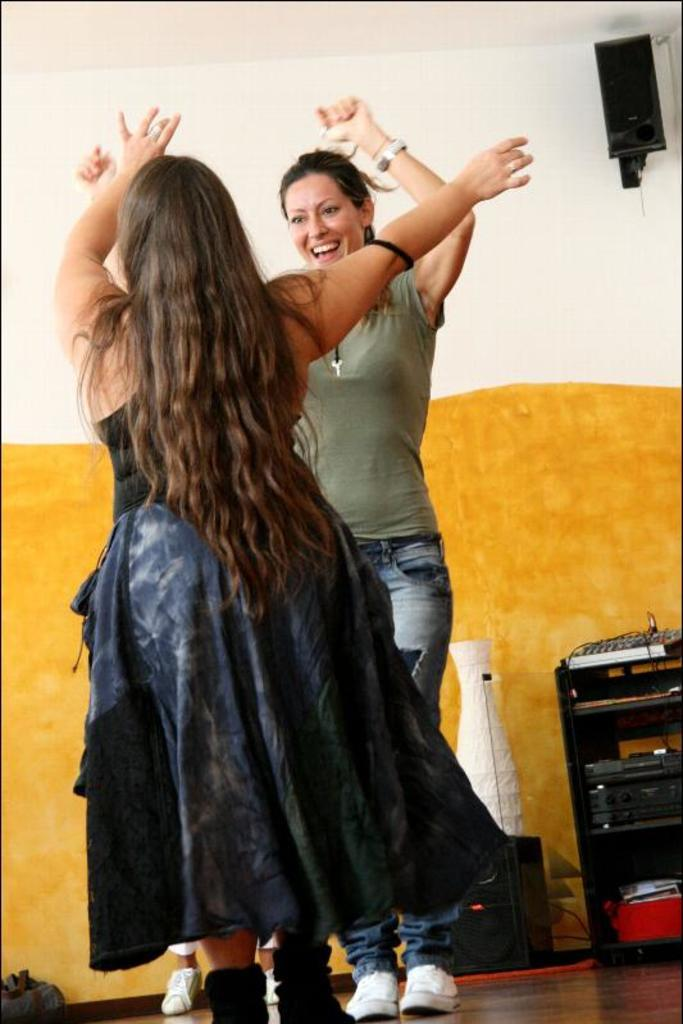How many people are in the image? There are two women in the image. What are the women doing in the image? The women are dancing on the floor. What can be seen in the background of the image? There are speakers, devices, and a wall in the background of the image. What type of grain is being used as a prop in the image? There is no grain present in the image. What toys can be seen on the floor while the women are dancing? There are no toys visible in the image; the women are dancing on the floor without any toys present. 